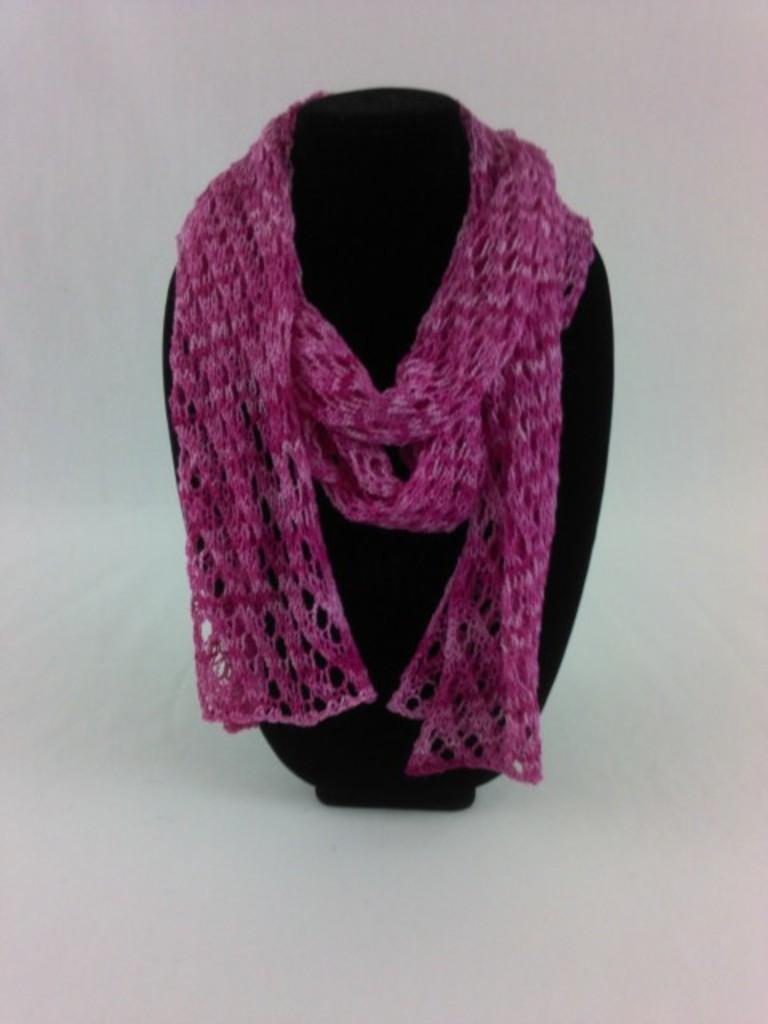Please provide a concise description of this image. In this image we can see a pink color stole on the black color object which is placed on the white surface. 